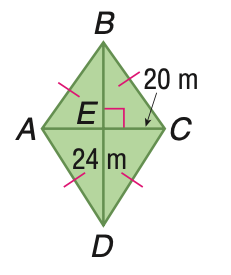Answer the mathemtical geometry problem and directly provide the correct option letter.
Question: Find the area of the quadrilateral.
Choices: A: 120 B: 240 C: 360 D: 480 B 